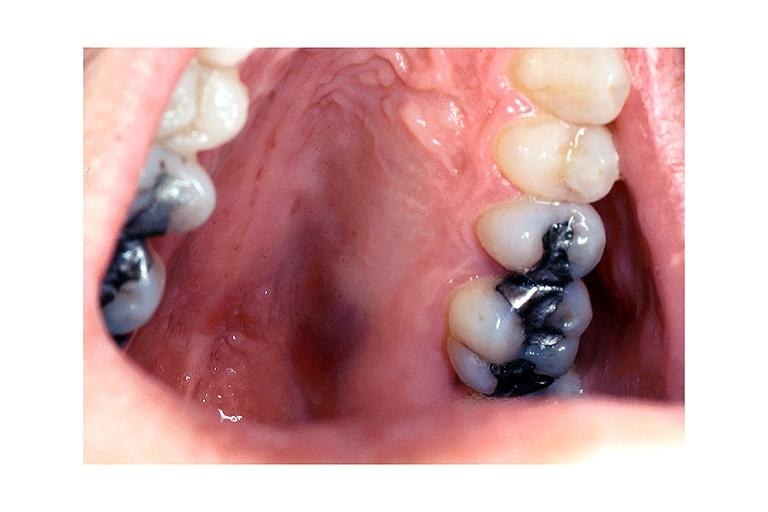what does this image show?
Answer the question using a single word or phrase. Kaposi sarcoma 